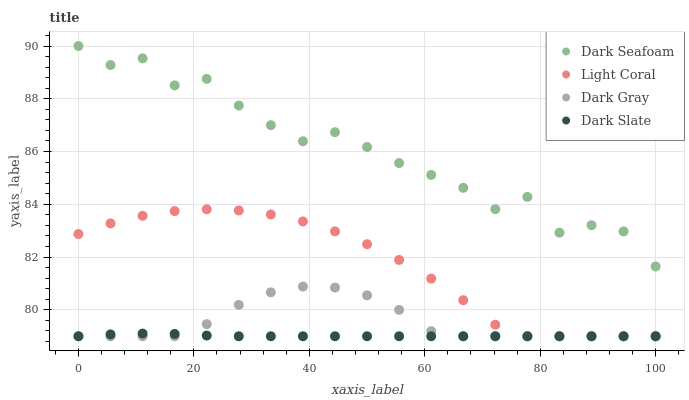Does Dark Slate have the minimum area under the curve?
Answer yes or no. Yes. Does Dark Seafoam have the maximum area under the curve?
Answer yes or no. Yes. Does Dark Gray have the minimum area under the curve?
Answer yes or no. No. Does Dark Gray have the maximum area under the curve?
Answer yes or no. No. Is Dark Slate the smoothest?
Answer yes or no. Yes. Is Dark Seafoam the roughest?
Answer yes or no. Yes. Is Dark Gray the smoothest?
Answer yes or no. No. Is Dark Gray the roughest?
Answer yes or no. No. Does Light Coral have the lowest value?
Answer yes or no. Yes. Does Dark Seafoam have the lowest value?
Answer yes or no. No. Does Dark Seafoam have the highest value?
Answer yes or no. Yes. Does Dark Gray have the highest value?
Answer yes or no. No. Is Light Coral less than Dark Seafoam?
Answer yes or no. Yes. Is Dark Seafoam greater than Dark Slate?
Answer yes or no. Yes. Does Light Coral intersect Dark Gray?
Answer yes or no. Yes. Is Light Coral less than Dark Gray?
Answer yes or no. No. Is Light Coral greater than Dark Gray?
Answer yes or no. No. Does Light Coral intersect Dark Seafoam?
Answer yes or no. No. 